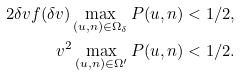Convert formula to latex. <formula><loc_0><loc_0><loc_500><loc_500>2 \delta v f ( \delta v ) \max _ { ( u , n ) \in \Omega _ { \delta } } P ( u , n ) < 1 / 2 , \\ v ^ { 2 } \max _ { ( u , n ) \in \Omega ^ { \prime } } P ( u , n ) < 1 / 2 .</formula> 